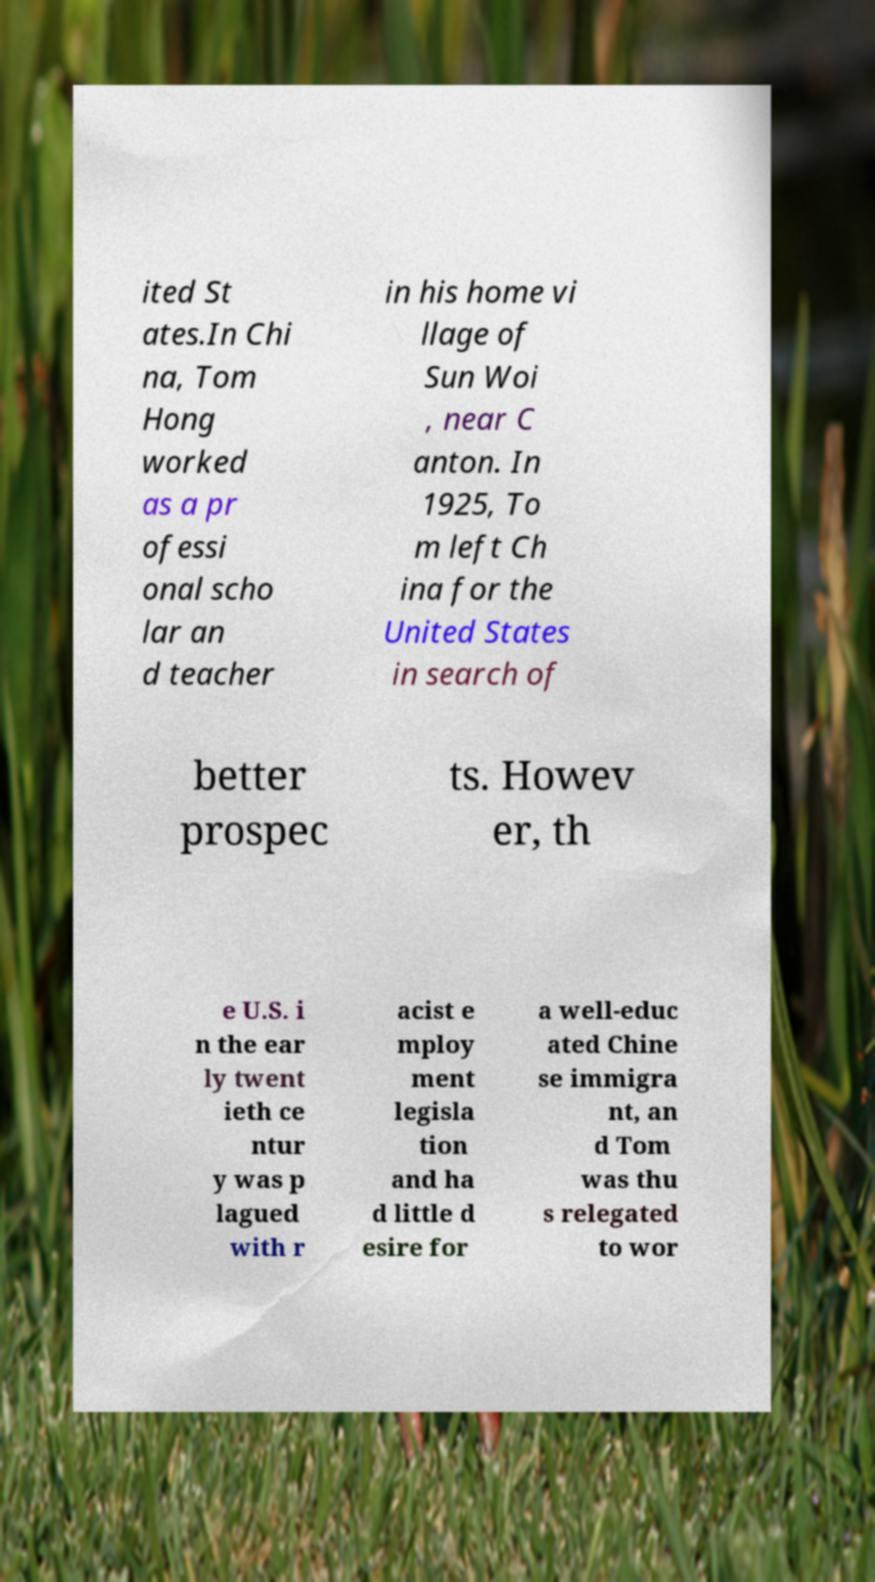There's text embedded in this image that I need extracted. Can you transcribe it verbatim? ited St ates.In Chi na, Tom Hong worked as a pr ofessi onal scho lar an d teacher in his home vi llage of Sun Woi , near C anton. In 1925, To m left Ch ina for the United States in search of better prospec ts. Howev er, th e U.S. i n the ear ly twent ieth ce ntur y was p lagued with r acist e mploy ment legisla tion and ha d little d esire for a well-educ ated Chine se immigra nt, an d Tom was thu s relegated to wor 